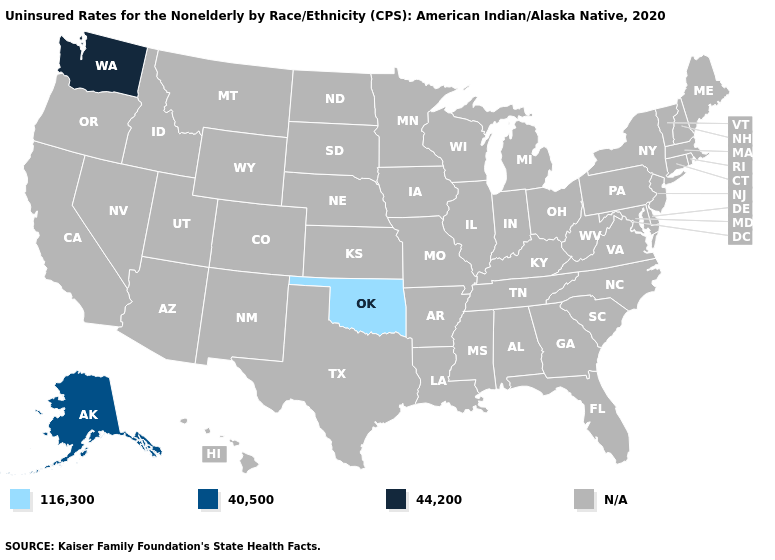Does Washington have the highest value in the USA?
Concise answer only. Yes. How many symbols are there in the legend?
Be succinct. 4. What is the value of Ohio?
Answer briefly. N/A. Which states hav the highest value in the West?
Write a very short answer. Washington. Does the first symbol in the legend represent the smallest category?
Answer briefly. Yes. Which states have the highest value in the USA?
Be succinct. Washington. Does Alaska have the lowest value in the USA?
Short answer required. No. Which states have the highest value in the USA?
Concise answer only. Washington. Name the states that have a value in the range 44,200?
Concise answer only. Washington. Name the states that have a value in the range 44,200?
Be succinct. Washington. Name the states that have a value in the range 40,500?
Write a very short answer. Alaska. What is the value of South Dakota?
Answer briefly. N/A. Name the states that have a value in the range 116,300?
Keep it brief. Oklahoma. 